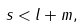Convert formula to latex. <formula><loc_0><loc_0><loc_500><loc_500>s < l + m ,</formula> 